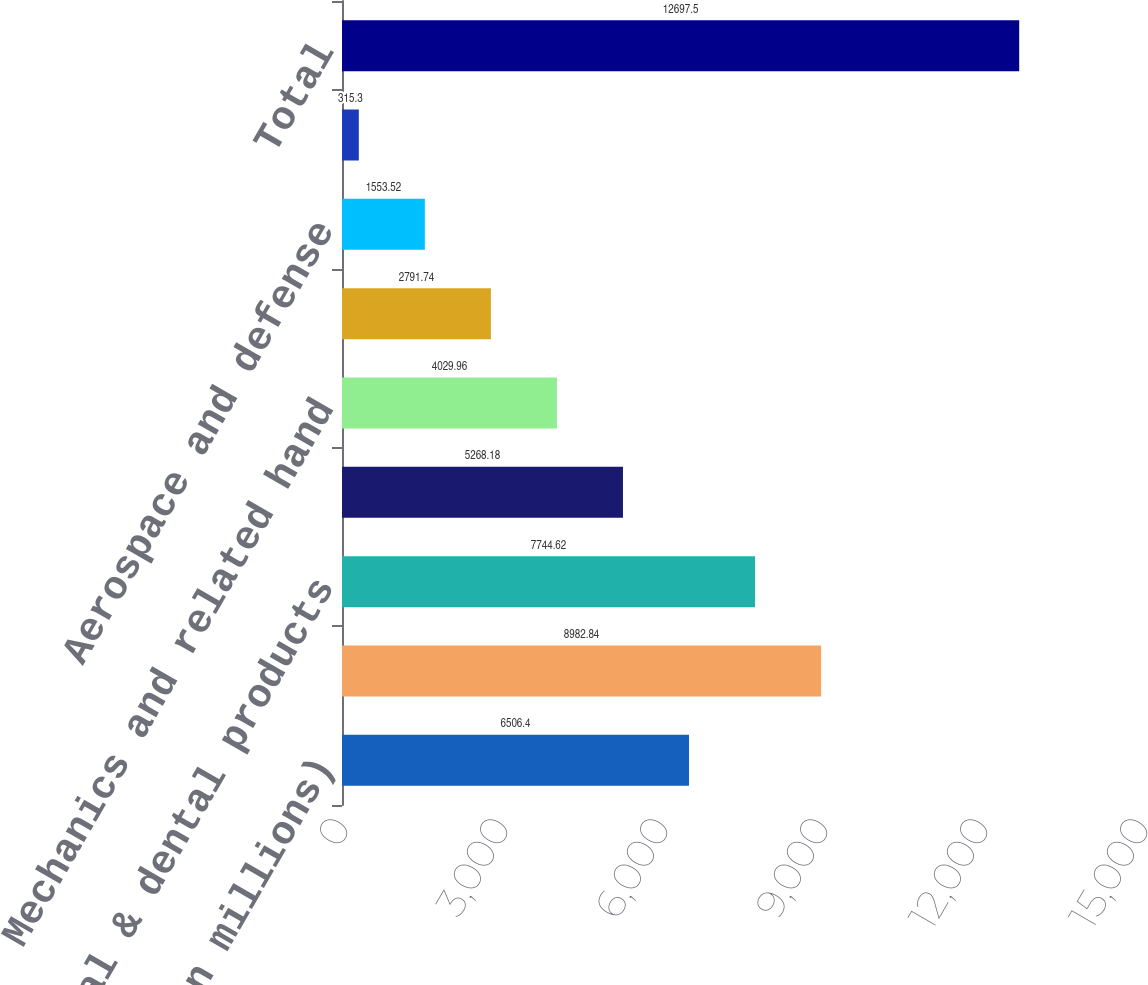Convert chart to OTSL. <chart><loc_0><loc_0><loc_500><loc_500><bar_chart><fcel>( in millions)<fcel>Analytical and physical<fcel>Medical & dental products<fcel>Motion and industrial<fcel>Mechanics and related hand<fcel>Product identification<fcel>Aerospace and defense<fcel>All other<fcel>Total<nl><fcel>6506.4<fcel>8982.84<fcel>7744.62<fcel>5268.18<fcel>4029.96<fcel>2791.74<fcel>1553.52<fcel>315.3<fcel>12697.5<nl></chart> 